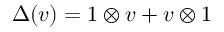Convert formula to latex. <formula><loc_0><loc_0><loc_500><loc_500>\Delta ( v ) = 1 \otimes v + v \otimes 1</formula> 